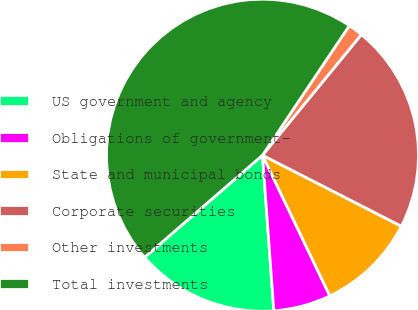<chart> <loc_0><loc_0><loc_500><loc_500><pie_chart><fcel>US government and agency<fcel>Obligations of government-<fcel>State and municipal bonds<fcel>Corporate securities<fcel>Other investments<fcel>Total investments<nl><fcel>14.8%<fcel>5.95%<fcel>10.37%<fcel>21.6%<fcel>1.53%<fcel>45.76%<nl></chart> 